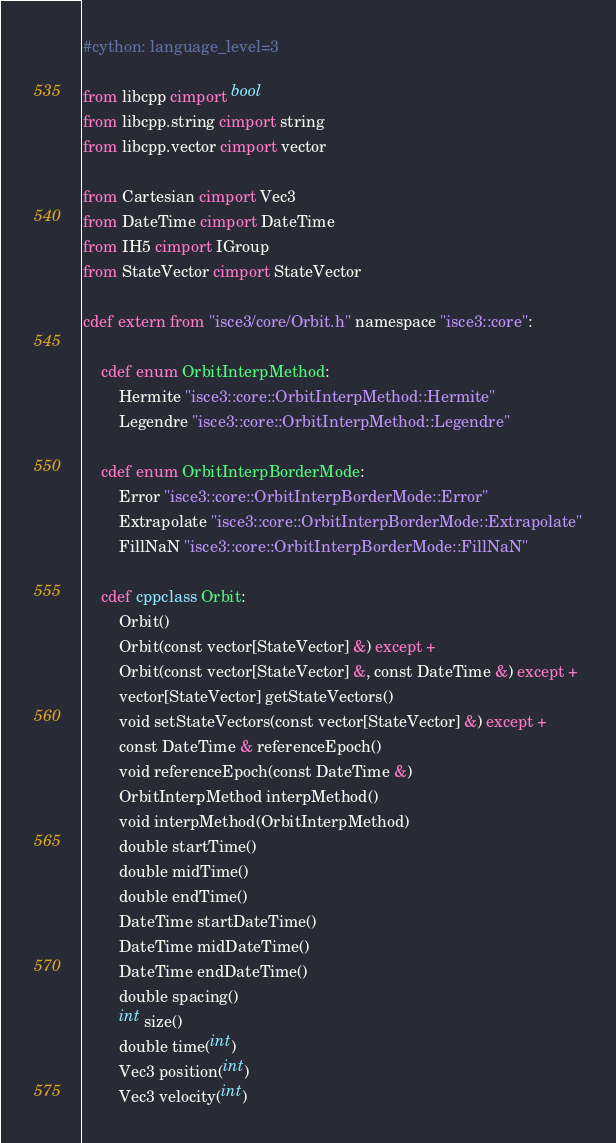<code> <loc_0><loc_0><loc_500><loc_500><_Cython_>#cython: language_level=3

from libcpp cimport bool
from libcpp.string cimport string
from libcpp.vector cimport vector

from Cartesian cimport Vec3
from DateTime cimport DateTime
from IH5 cimport IGroup
from StateVector cimport StateVector

cdef extern from "isce3/core/Orbit.h" namespace "isce3::core":

    cdef enum OrbitInterpMethod:
        Hermite "isce3::core::OrbitInterpMethod::Hermite"
        Legendre "isce3::core::OrbitInterpMethod::Legendre"

    cdef enum OrbitInterpBorderMode:
        Error "isce3::core::OrbitInterpBorderMode::Error"
        Extrapolate "isce3::core::OrbitInterpBorderMode::Extrapolate"
        FillNaN "isce3::core::OrbitInterpBorderMode::FillNaN"

    cdef cppclass Orbit:
        Orbit()
        Orbit(const vector[StateVector] &) except +
        Orbit(const vector[StateVector] &, const DateTime &) except +
        vector[StateVector] getStateVectors()
        void setStateVectors(const vector[StateVector] &) except +
        const DateTime & referenceEpoch()
        void referenceEpoch(const DateTime &)
        OrbitInterpMethod interpMethod()
        void interpMethod(OrbitInterpMethod)
        double startTime()
        double midTime()
        double endTime()
        DateTime startDateTime()
        DateTime midDateTime()
        DateTime endDateTime()
        double spacing()
        int size()
        double time(int)
        Vec3 position(int)
        Vec3 velocity(int)</code> 